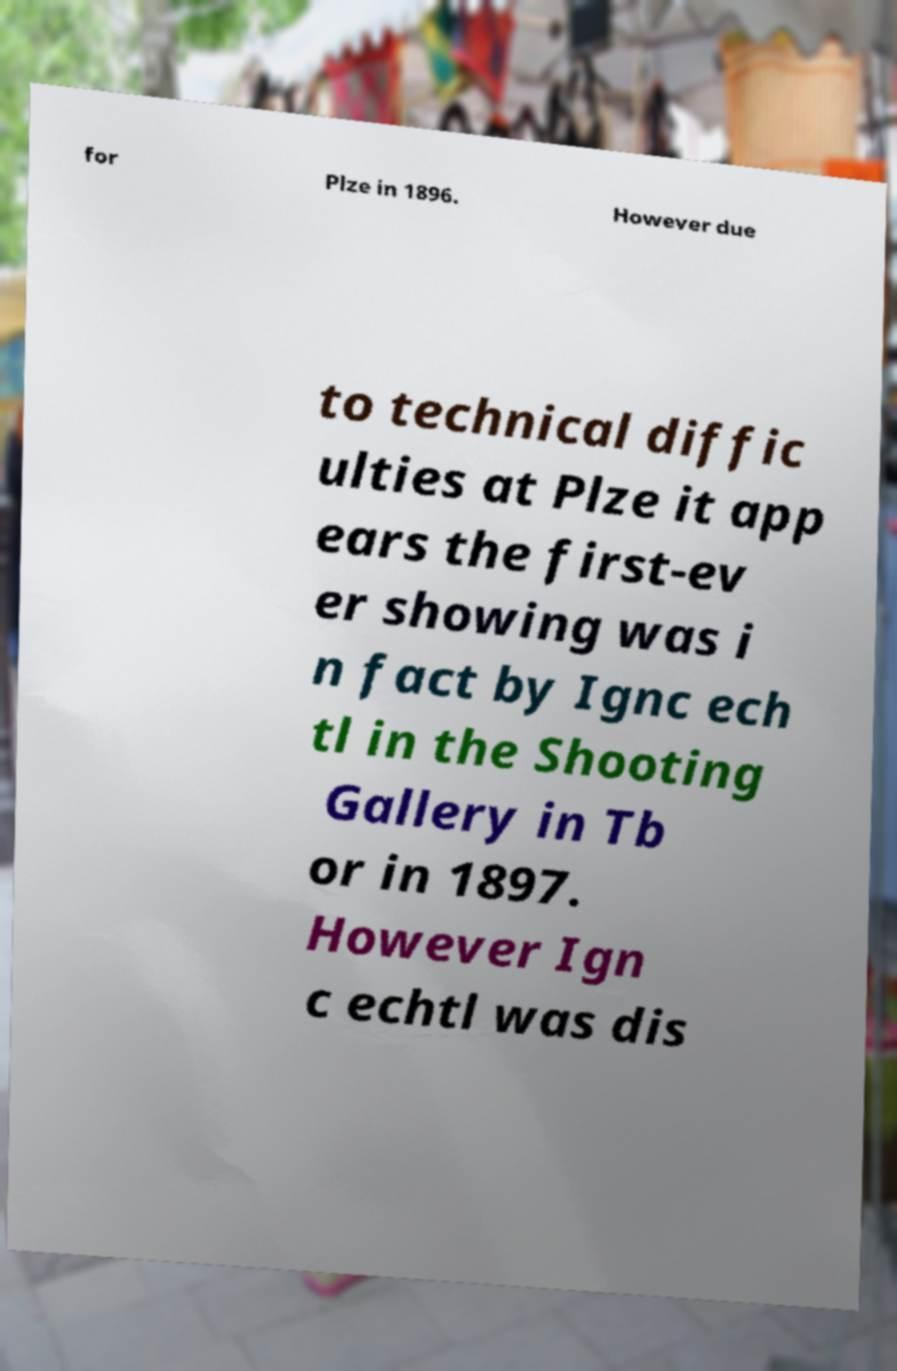For documentation purposes, I need the text within this image transcribed. Could you provide that? for Plze in 1896. However due to technical diffic ulties at Plze it app ears the first-ev er showing was i n fact by Ignc ech tl in the Shooting Gallery in Tb or in 1897. However Ign c echtl was dis 